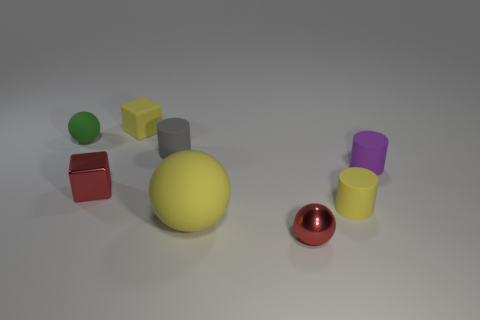Subtract all rubber spheres. How many spheres are left? 1 Subtract 0 red cylinders. How many objects are left? 8 Subtract all blocks. How many objects are left? 6 Subtract 2 blocks. How many blocks are left? 0 Subtract all gray spheres. Subtract all green cylinders. How many spheres are left? 3 Subtract all purple cylinders. How many yellow cubes are left? 1 Subtract all metallic cylinders. Subtract all tiny purple cylinders. How many objects are left? 7 Add 3 small red shiny things. How many small red shiny things are left? 5 Add 8 tiny red balls. How many tiny red balls exist? 9 Add 2 small cyan rubber objects. How many objects exist? 10 